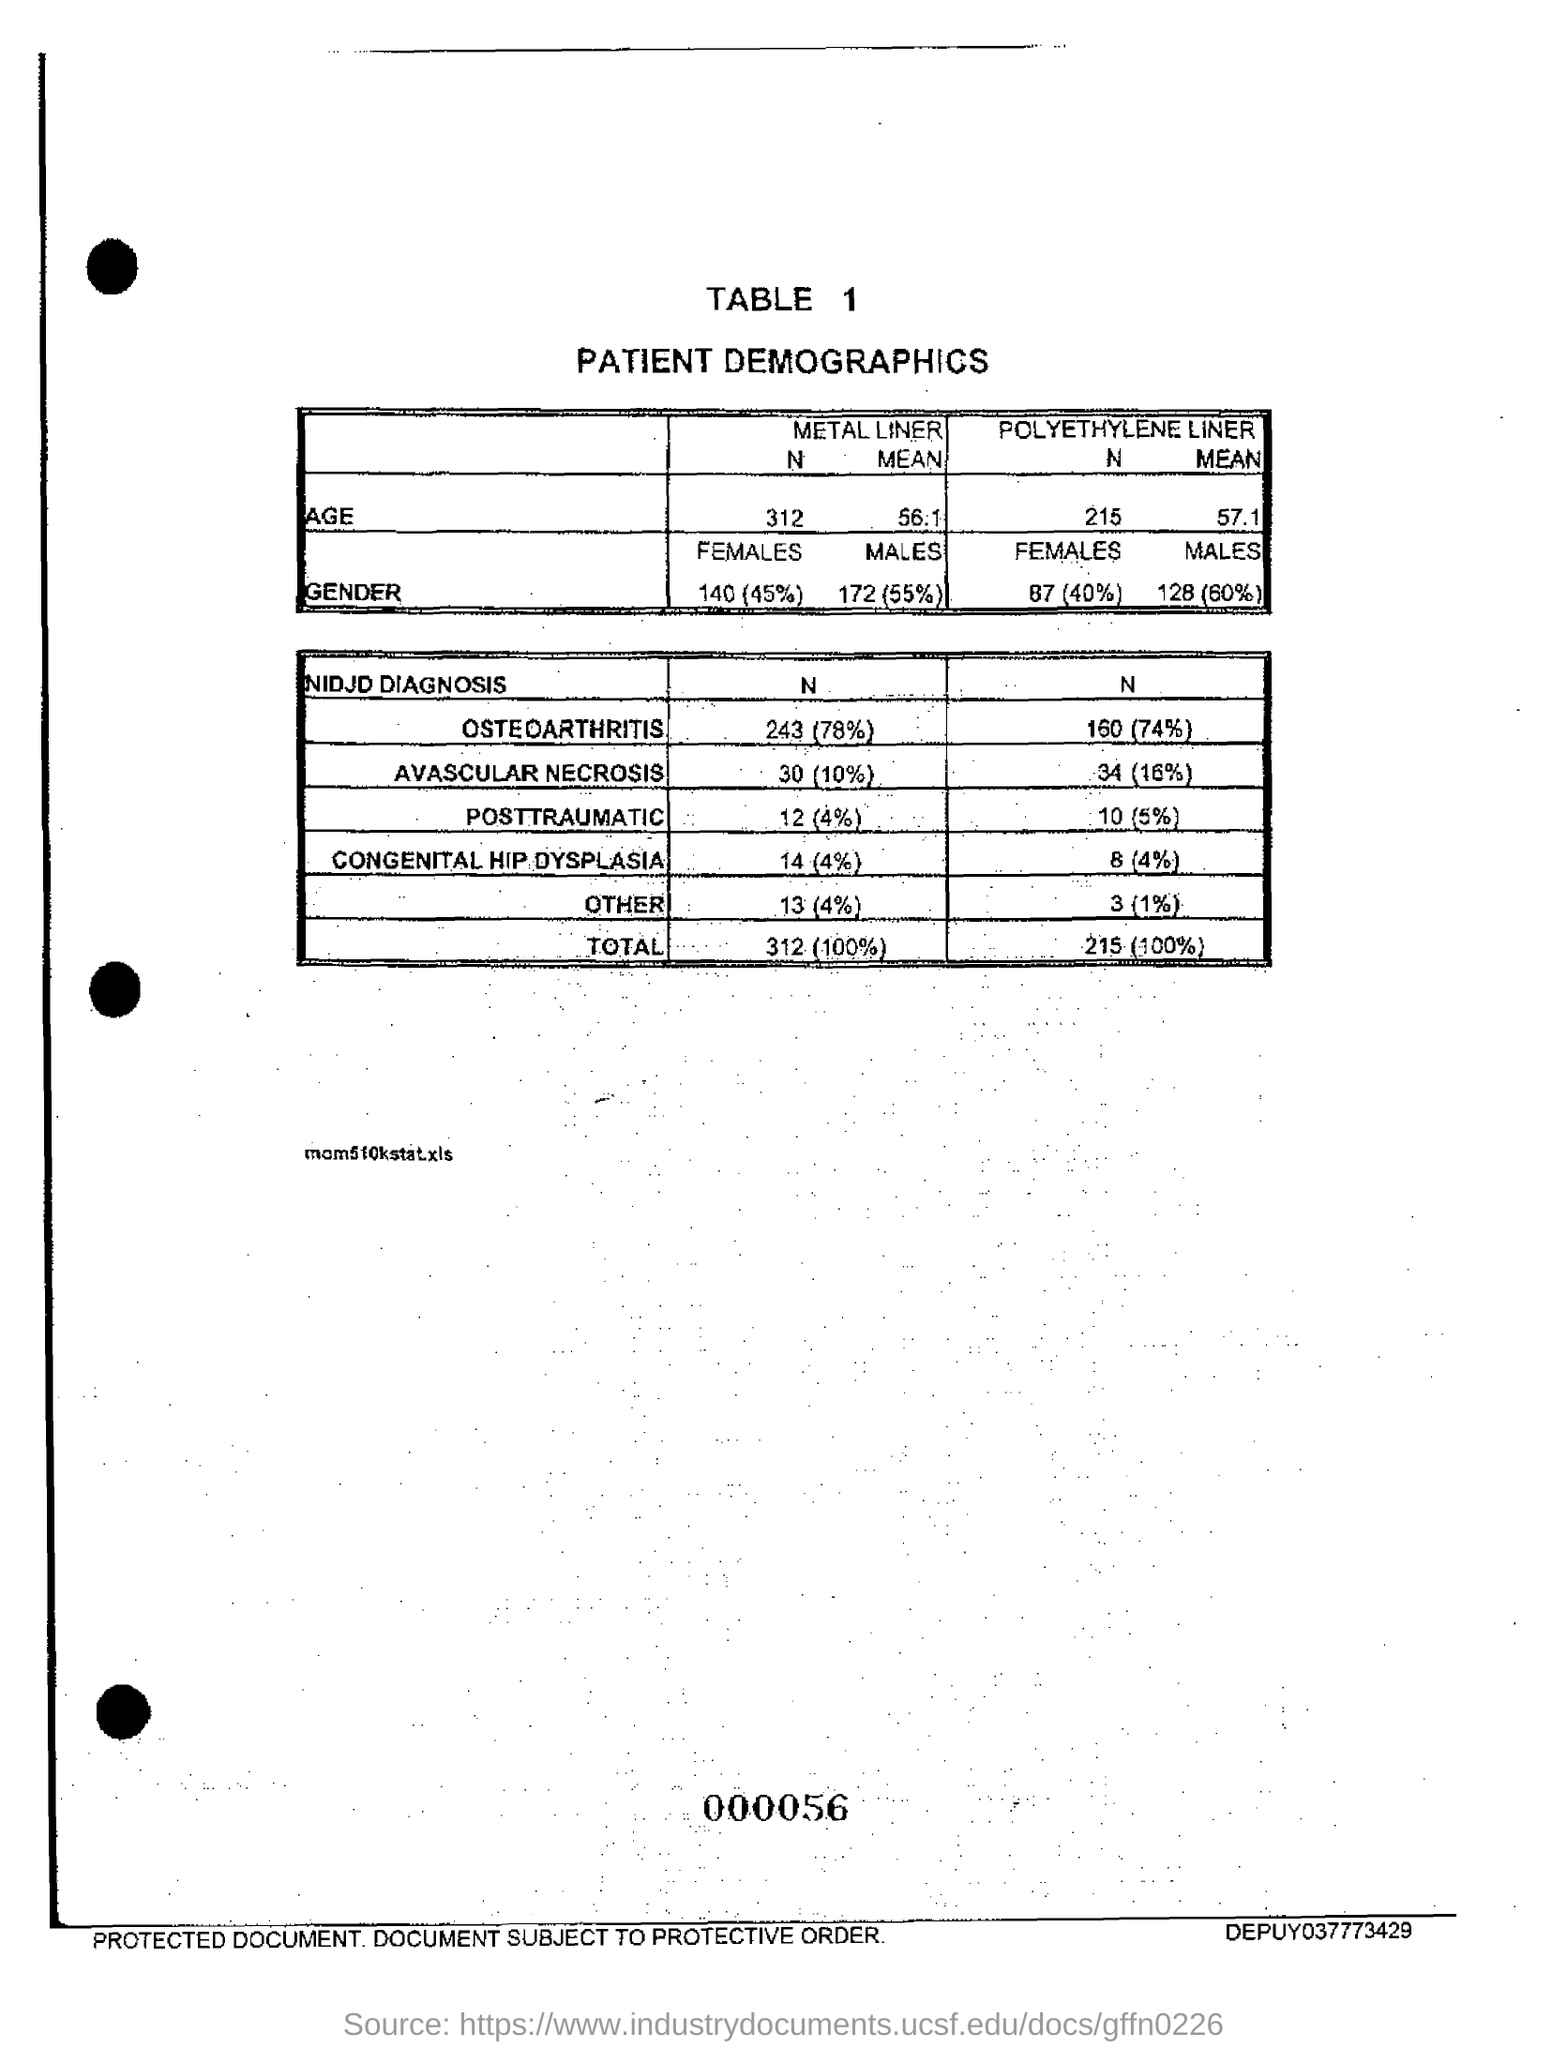Mention a couple of crucial points in this snapshot. A study found that approximately 78% of osteoarthritis patients with metal liners in their total knee replacements experienced good to excellent pain relief and functional improvement. 